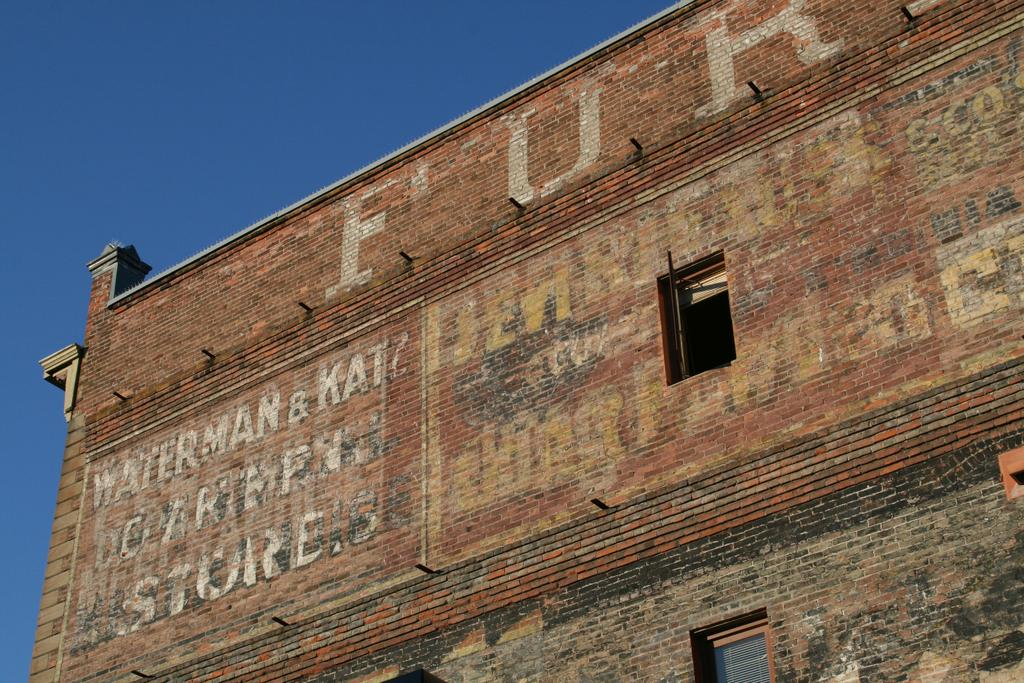What type of structure is present in the image? There is a building in the image. What features can be observed on the building? The building has windows and a brick wall. What is the color of the sky in the image? The sky is blue in color. What type of pump can be seen attached to the building in the image? There is no pump present in the image; it only features a building with windows and a brick wall. What type of food is being prepared in the building in the image? There is no indication of food preparation or any food items in the image. 